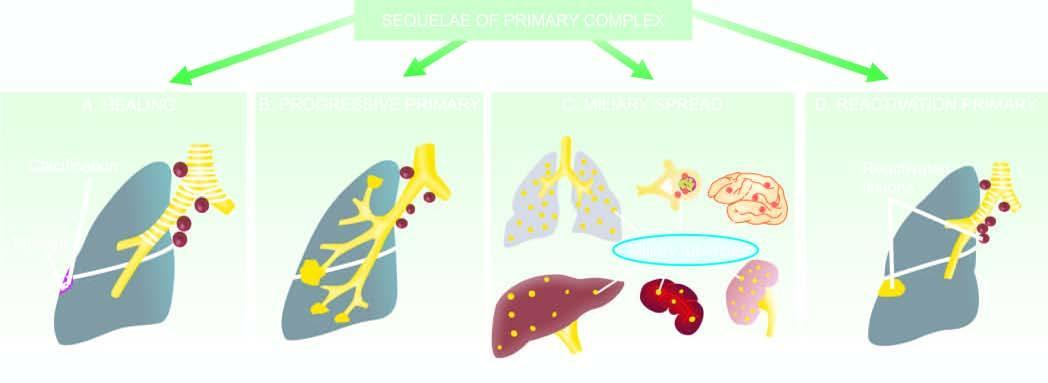what did miliary spread to?
Answer the question using a single word or phrase. Lungs 